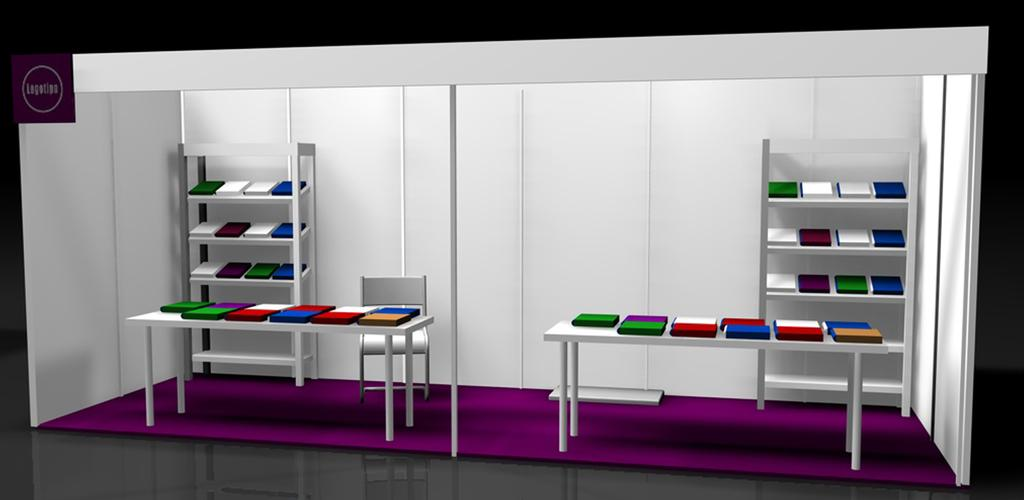What type of image is being described? The image is graphical in nature. What can be seen on the table in the image? There are things on a table in the image. What is the location of the other items in the image? The other items are in the background in racks in the image. What type of street is visible in the image? There is no street visible in the image; it is a graphical image with items on a table and other items in the background in racks. 